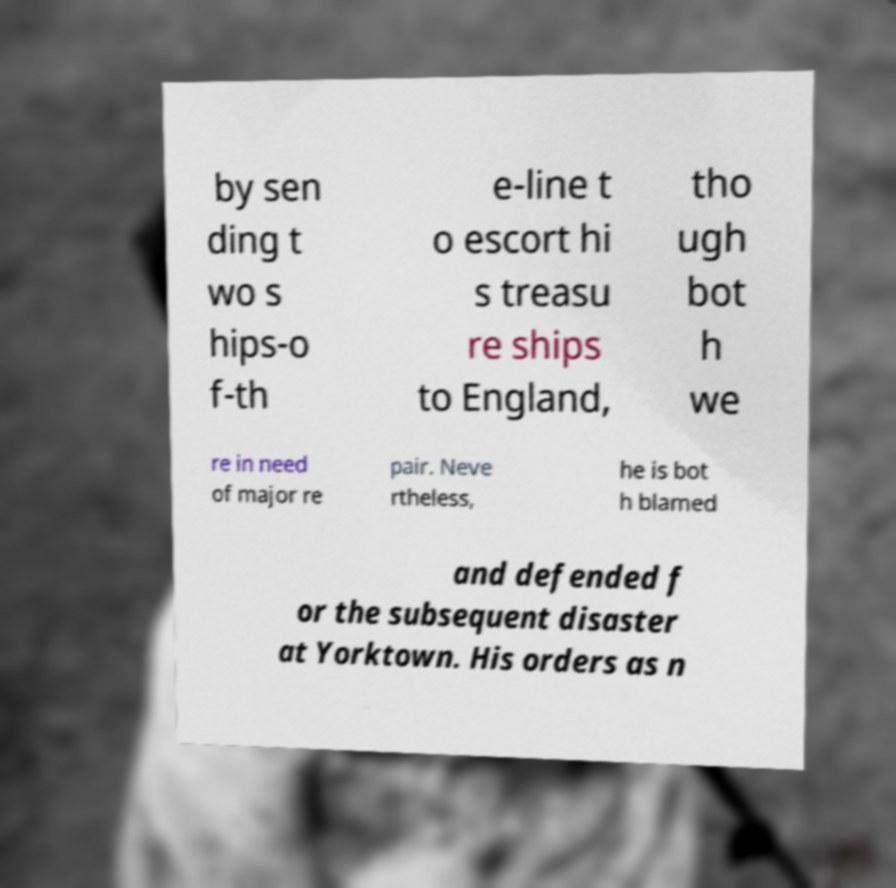I need the written content from this picture converted into text. Can you do that? by sen ding t wo s hips-o f-th e-line t o escort hi s treasu re ships to England, tho ugh bot h we re in need of major re pair. Neve rtheless, he is bot h blamed and defended f or the subsequent disaster at Yorktown. His orders as n 